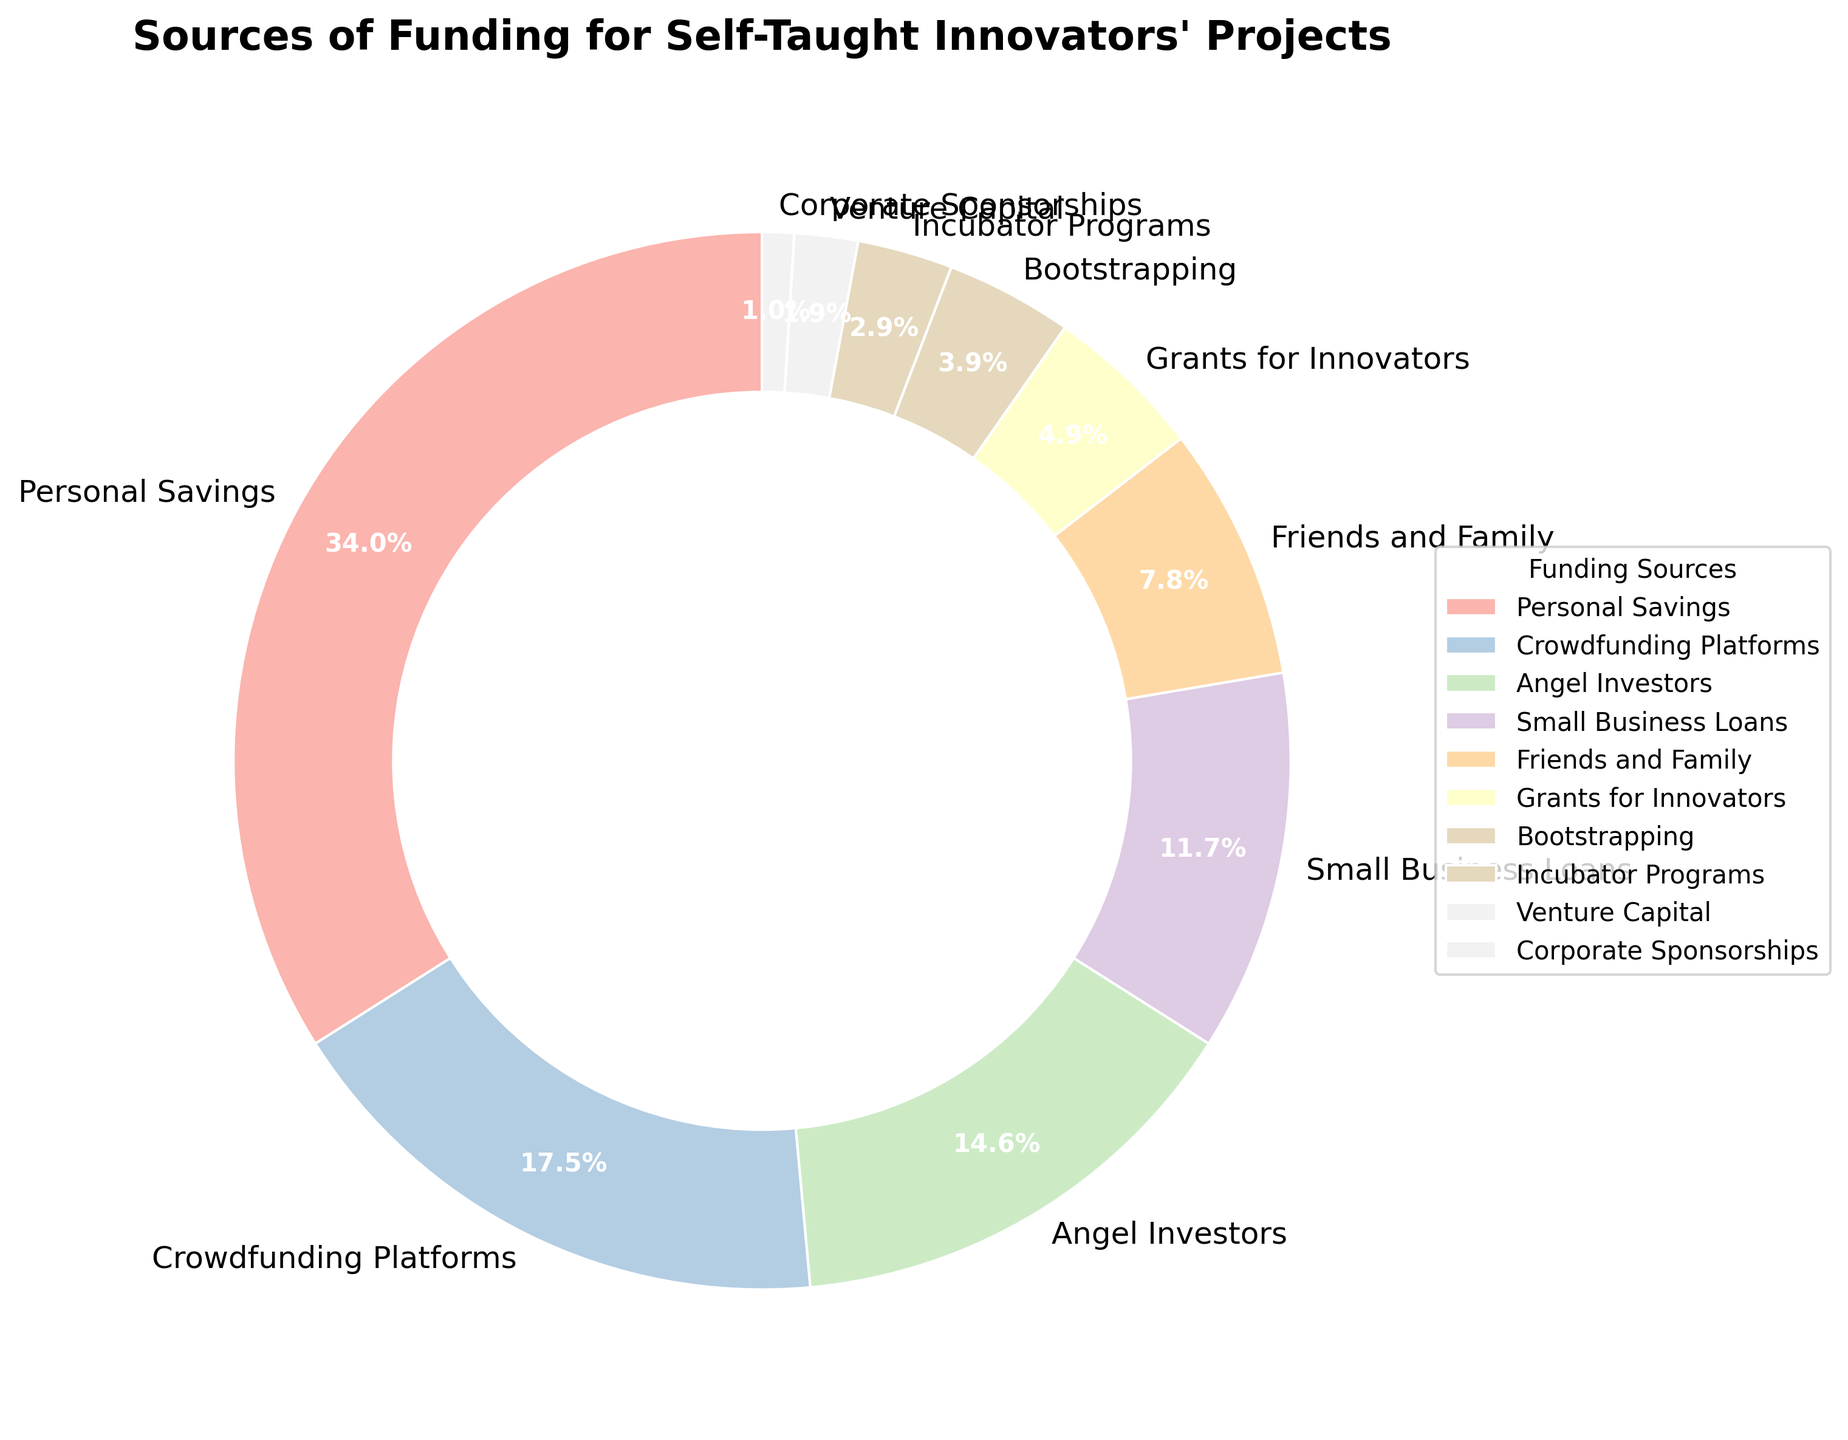What's the most common source of funding for self-taught innovators' projects? The segment labeled "Personal Savings" is the largest, comprising 35% of the funding sources according to the pie chart.
Answer: Personal Savings Which two funding sources combined contribute to less than one-fourth of the total funding? The segments labeled "Incubator Programs" and "Venture Capital" are 3% and 2%, respectively. Adding these percentages gives 3% + 2% = 5%, which is less than 25%.
Answer: Incubator Programs and Venture Capital What is the difference in percentage between Crowdfunding Platforms and Small Business Loans? The Pie Chart shows Crowdfunding Platforms at 18% and Small Business Loans at 12%. The difference is calculated by 18% - 12% = 6%.
Answer: 6% Which funding source is represented by a segment significantly smaller than 10% but larger than 5%? The segment for "Friends and Family" is labeled as 8%, which fits the criteria of being less than 10% but more than 5%.
Answer: Friends and Family What percentage of the total funding is contributed by sources that each account for less than 10%? The funding sources below 10% are Friends and Family (8%), Grants for Innovators (5%), Bootstrapping (4%), Incubator Programs (3%), Venture Capital (2%), and Corporate Sponsorships (1%). Summing these gives: 8% + 5% + 4% + 3% + 2% + 1% = 23%.
Answer: 23% Which two funding sources have a combined percentage equal to that of Personal Savings? The "Crowdfunding Platforms" and "Angel Investors" segments are 18% and 15%, respectively. Adding these percentages gives 18% + 15% = 33%, which does not match 35%. Instead, "Friends and Family" (8%) and "Small Business Loans" (12%) combined with "Angel Investors" (15%) give 8% + 12% + 15% = 35%.
Answer: Friends and Family, Small Business Loans, and Angel Investors Among the funding sources that each contribute less than 5%, which one is smallest? According to the pie chart, "Corporate Sponsorships" is labeled as 1%, which is the smallest figure among those below 5%.
Answer: Corporate Sponsorships How much more is the percentage of Angel Investors compared to that of Bootstrapping? Angel Investors contribute 15% and Bootstrapping contributes 4%, the difference is calculated by 15% - 4% = 11%.
Answer: 11% What is the total percentage contribution of Grants for Innovators and Small Business Loans combined? The pie chart shows Grants for Innovators at 5% and Small Business Loans at 12%. Adding these two percentages gives 5% + 12% = 17%.
Answer: 17% 